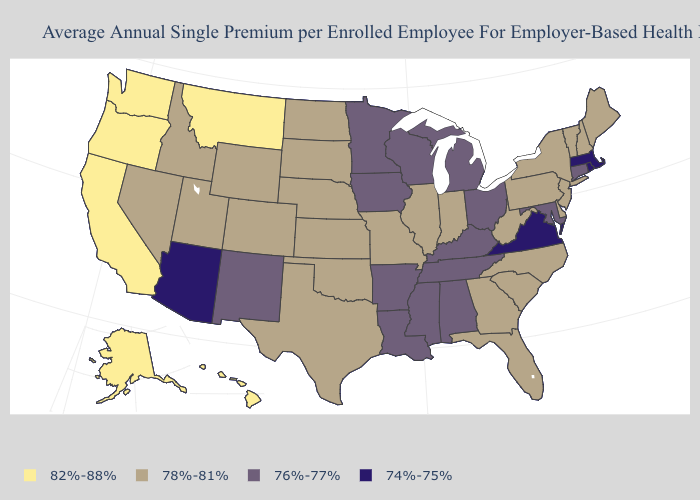Name the states that have a value in the range 76%-77%?
Write a very short answer. Alabama, Arkansas, Connecticut, Iowa, Kentucky, Louisiana, Maryland, Michigan, Minnesota, Mississippi, New Mexico, Ohio, Tennessee, Wisconsin. What is the value of Iowa?
Be succinct. 76%-77%. What is the lowest value in states that border Rhode Island?
Short answer required. 74%-75%. What is the value of Maryland?
Keep it brief. 76%-77%. Which states have the highest value in the USA?
Short answer required. Alaska, California, Hawaii, Montana, Oregon, Washington. What is the value of Louisiana?
Give a very brief answer. 76%-77%. What is the value of Kentucky?
Be succinct. 76%-77%. Does Nebraska have the same value as South Dakota?
Give a very brief answer. Yes. Does Colorado have a higher value than Connecticut?
Give a very brief answer. Yes. What is the value of Massachusetts?
Be succinct. 74%-75%. What is the highest value in the USA?
Quick response, please. 82%-88%. What is the value of Texas?
Be succinct. 78%-81%. What is the value of West Virginia?
Be succinct. 78%-81%. Name the states that have a value in the range 76%-77%?
Short answer required. Alabama, Arkansas, Connecticut, Iowa, Kentucky, Louisiana, Maryland, Michigan, Minnesota, Mississippi, New Mexico, Ohio, Tennessee, Wisconsin. What is the value of Nebraska?
Be succinct. 78%-81%. 